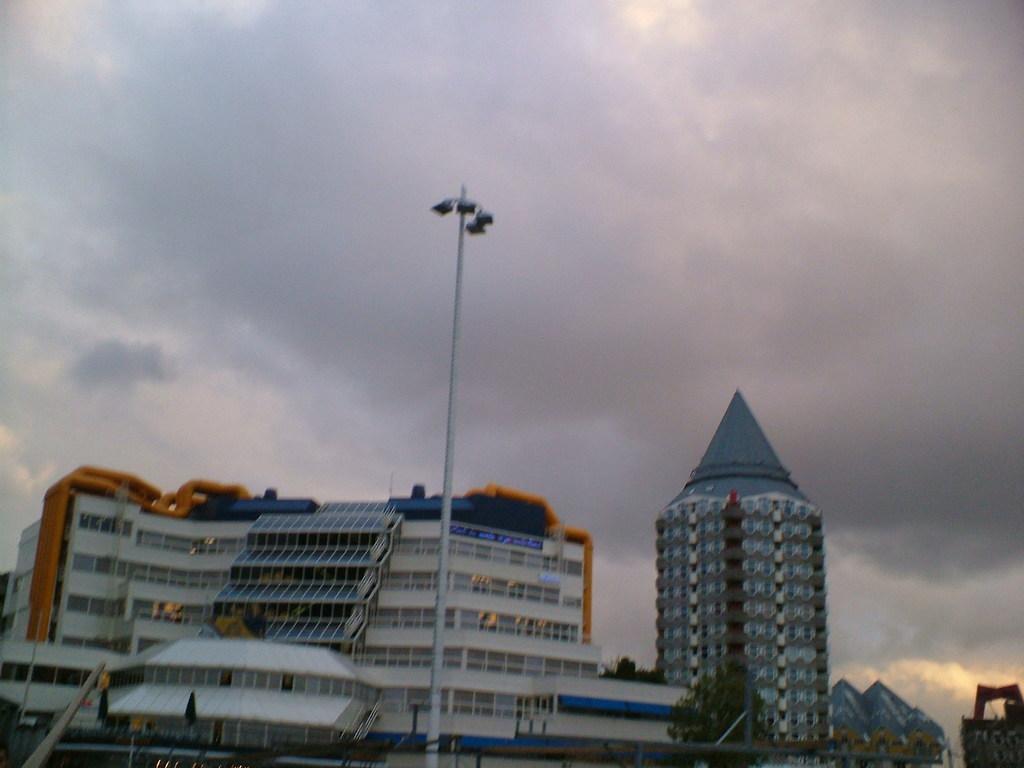Could you give a brief overview of what you see in this image? In this image I can see number of buildings and in the front of it I can see few poles and few lights. On the right side of this image I can see few trees and in the background I can see clouds and the sky. 